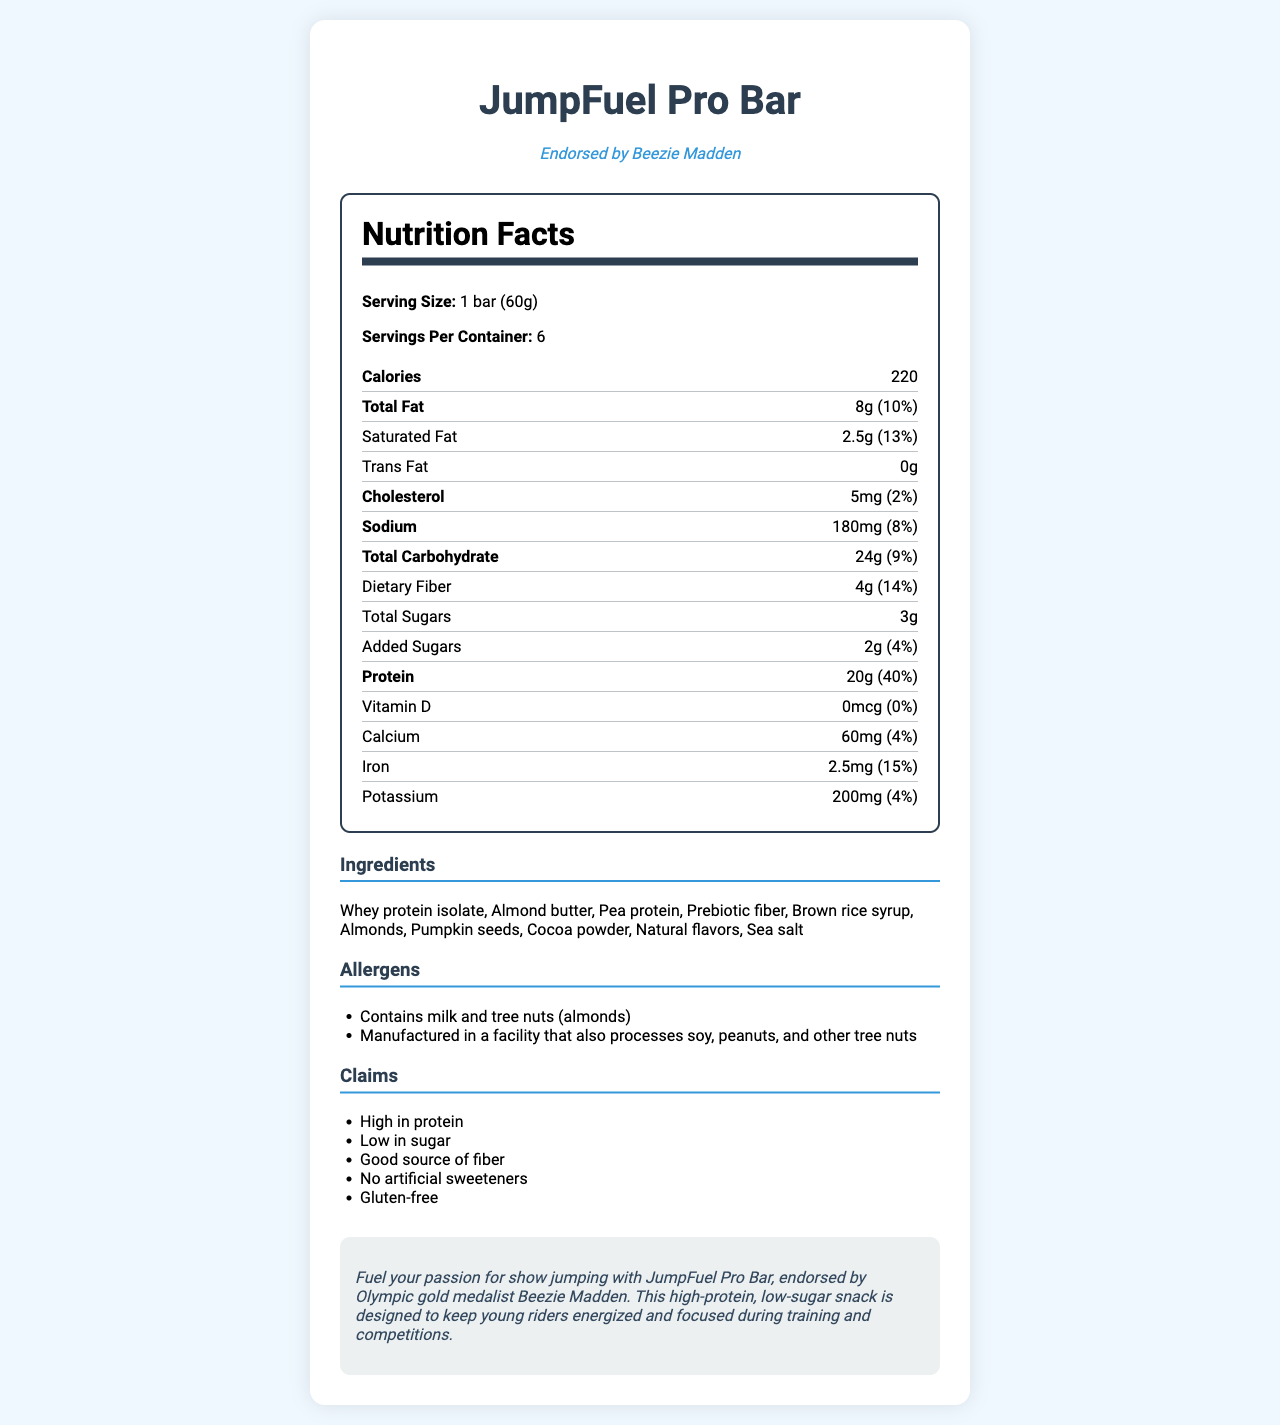what is the serving size of JumpFuel Pro Bar? The serving size is clearly listed at the top of the nutrition label under "Serving Size."
Answer: 1 bar (60g) How many servings are in each container of JumpFuel Pro Bar? The document states "Servings Per Container: 6."
Answer: 6 Which famous show jumper endorses the JumpFuel Pro Bar? It is mentioned in the document that the bar is endorsed by Beezie Madden.
Answer: Beezie Madden What is the total carbohydrate content in one bar of JumpFuel Pro Bar? The total carbohydrate content is listed as 24g in the nutrition label.
Answer: 24g What percentage of the daily value of protein does one serving of JumpFuel Pro Bar provide? The nutrition label indicates that the protein content per serving provides 40% of the daily value.
Answer: 40% How many grams of dietary fiber are in one bar? A. 2g B. 3g C. 4g D. 5g The nutrition label lists the amount of dietary fiber as 4g.
Answer: C. 4g What is the amount of calcium in one bar of JumpFuel Pro Bar? A. 30mg B. 40mg C. 50mg D. 60mg The amount of calcium per serving is listed as 60mg in the nutrition label.
Answer: D. 60mg Is the JumpFuel Pro Bar free of any artificial sweeteners? Under the "Claims" section, it states "No artificial sweeteners."
Answer: Yes Does the JumpFuel Pro Bar contain any peanuts? The allergen section mentions it's manufactured in a facility that processes peanuts, but it does not specify if peanuts are an ingredient.
Answer: Cannot be determined Summarize the main idea of the document. The summary captures the key points of the document: the product's purpose, endorsement, nutritional value, claims, ingredient list, and allergen information.
Answer: The JumpFuel Pro Bar is a high-protein, low-sugar snack bar endorsed by Olympic gold medalist Beezie Madden, designed to keep young riders energized and focused during training and competitions. It provides detailed nutritional information, highlights claims such as being high in protein and low in sugar, and lists ingredients and allergens. What is the total fat content in one serving of JumpFuel Pro Bar? The nutrition label shows the total fat content as 8g per serving.
Answer: 8g How many milligrams of sodium does one bar of JumpFuel Pro Bar contain? The sodium content per serving is listed as 180mg.
Answer: 180mg What are the first three ingredients listed for JumpFuel Pro Bar? The document lists these as the first three ingredients in the ingredients section.
Answer: Whey protein isolate, Almond butter, Pea protein What percentage of the daily value for saturated fat is in one bar? The nutrition label shows the daily value percentage for saturated fat as 13%.
Answer: 13% Are there any tree nuts in JumpFuel Pro Bar? The document states that it contains tree nuts (almonds) in the allergen section.
Answer: Yes 